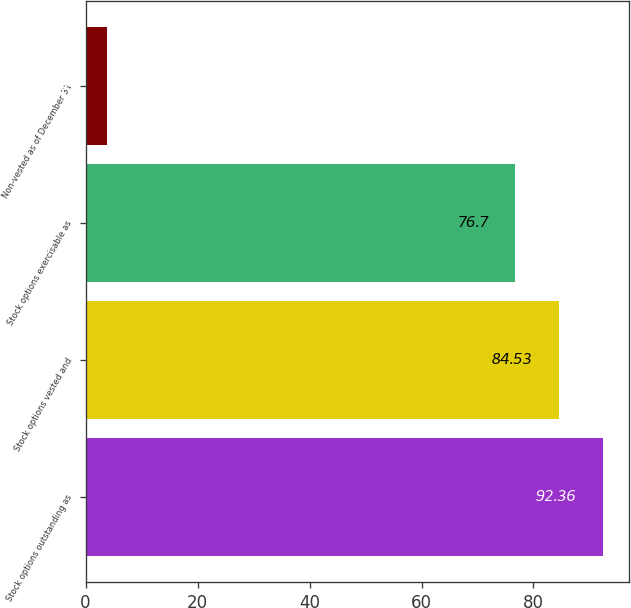Convert chart to OTSL. <chart><loc_0><loc_0><loc_500><loc_500><bar_chart><fcel>Stock options outstanding as<fcel>Stock options vested and<fcel>Stock options exercisable as<fcel>Non-vested as of December 31<nl><fcel>92.36<fcel>84.53<fcel>76.7<fcel>3.8<nl></chart> 